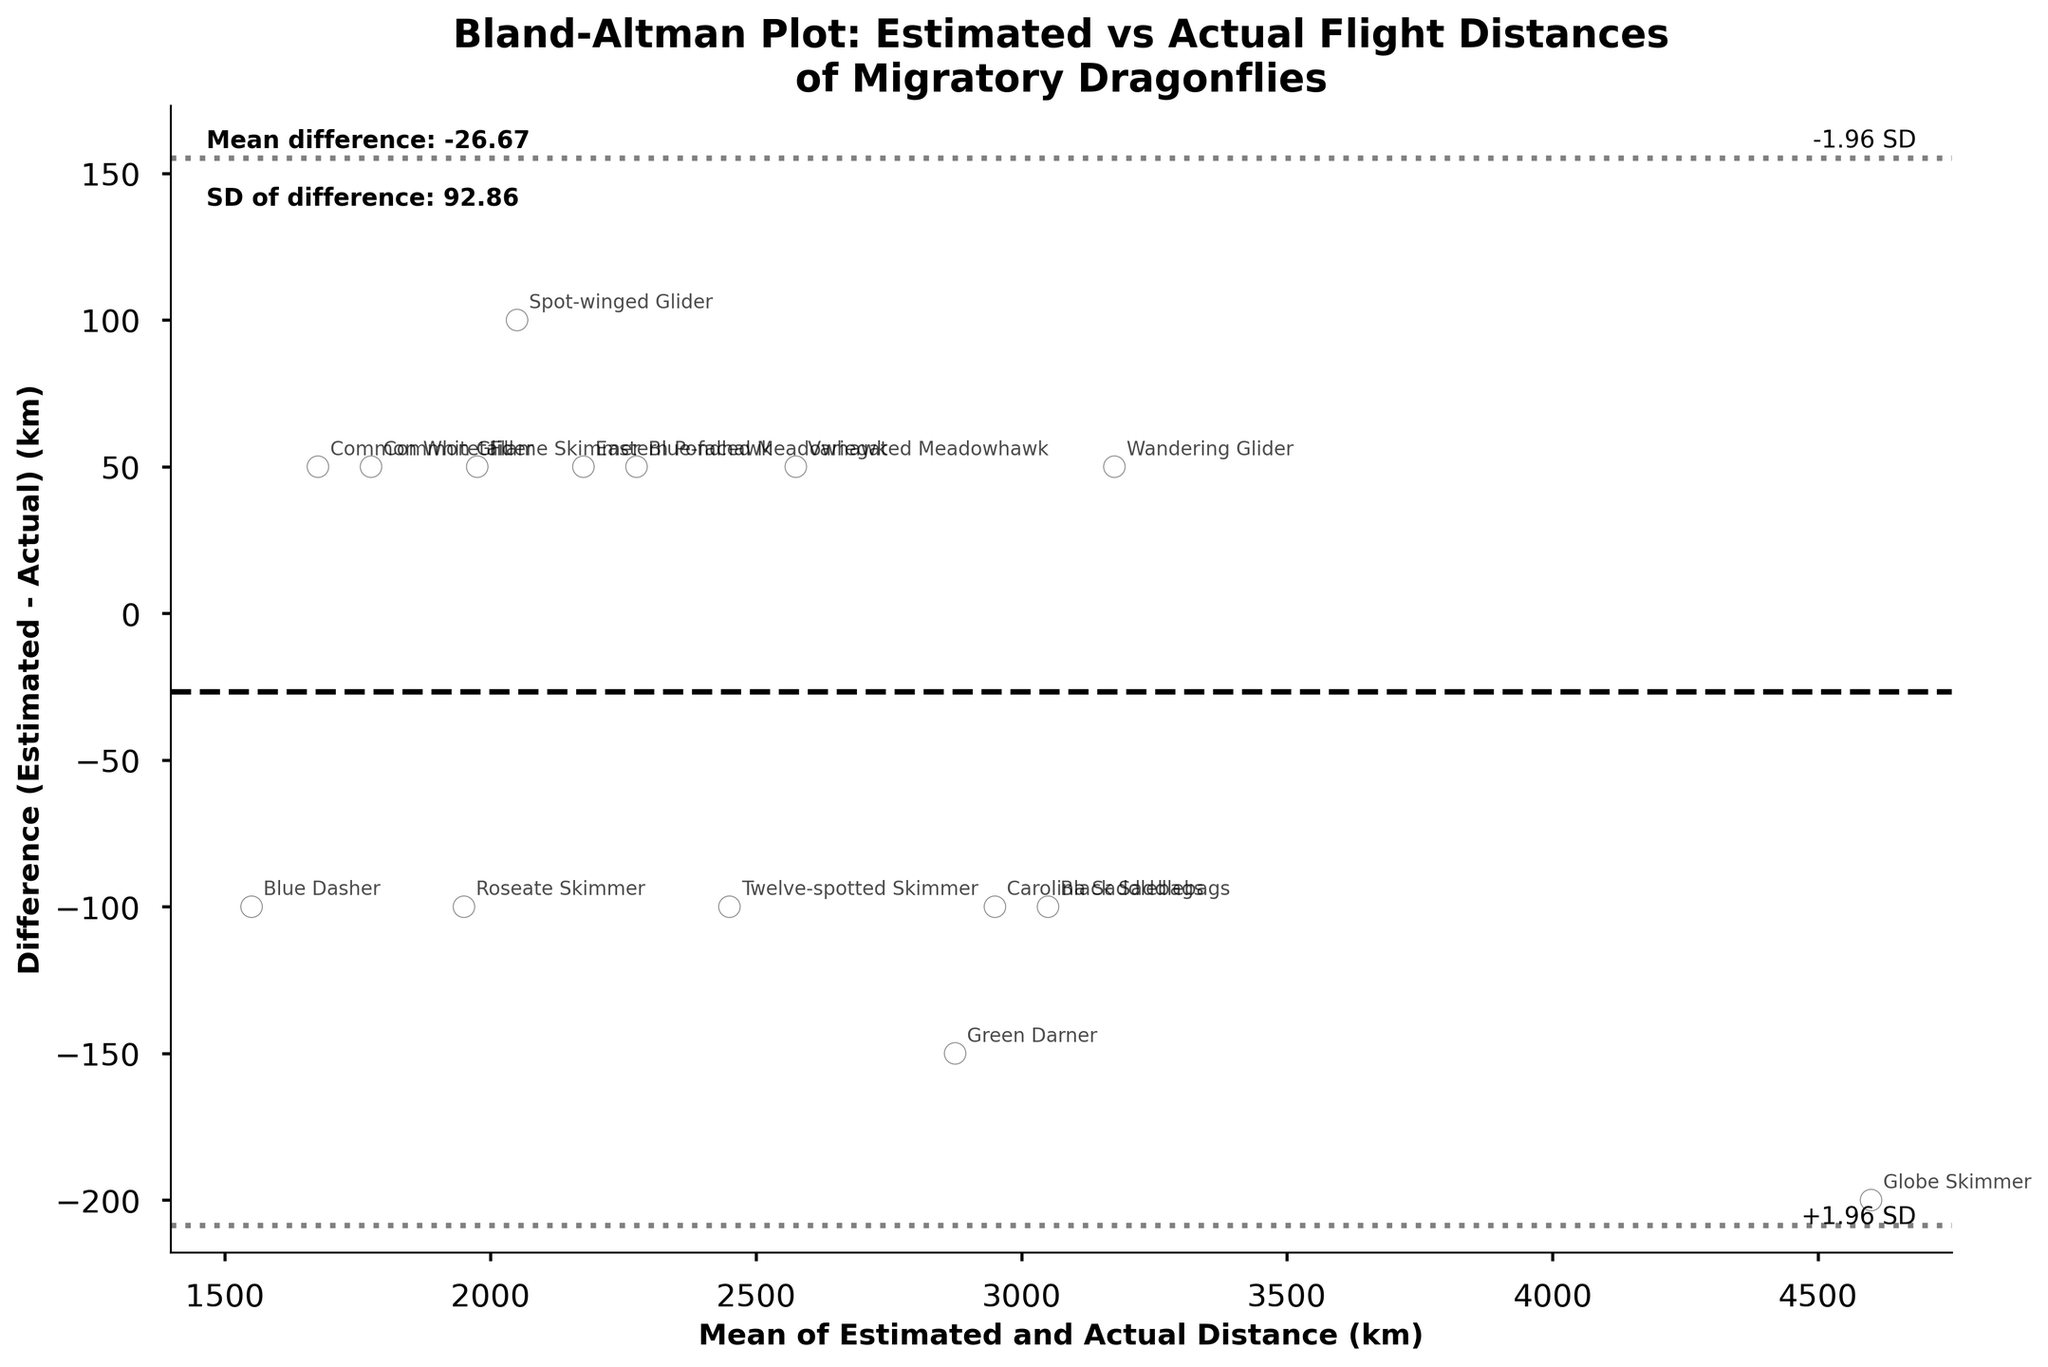What is the title of the plot? The title is usually found at the top of the plot and describes its overall content.
Answer: Bland-Altman Plot: Estimated vs Actual Flight Distances of Migratory Dragonflies How many dragonfly species are shown in the plot? Count the number of unique points or annotations on the plot, as each species is represented by a unique data point.
Answer: 15 What do the x-axis and y-axis represent in the plot? Read the labels on the axes to understand what each axis represents. The x-axis represents the mean of the estimated and actual distances, and the y-axis represents the difference between the estimated and actual distances.
Answer: The x-axis represents the Mean of Estimated and Actual Distance (km), and the y-axis represents the Difference (Estimated - Actual) (km) What does the dashed horizontal line in the middle of the plot represent? Observe the plot and describe the dashed line. It usually represents the mean difference which is marked as a reference line.
Answer: It represents the mean difference between the estimated and actual distances Which species is closest to the mean difference line? Identify the species annotated nearest to the dashed horizontal line representing the mean difference.
Answer: Roseate Skimmer What are the values of the mean difference and SD of the difference? Look for any textual information on the plot that details these statistics. It's usually found as annotations on the plot.
Answer: Mean difference: -23.33, SD of difference: 88.42 Which species has the largest positive difference between estimated and actual distances? Find the data point with the highest positive value on the y-axis and identify the species annotated at this position.
Answer: Common Glider Which species has the largest negative difference between estimated and actual distances? Find the data point with the lowest negative value on the y-axis and identify the species annotated at this position.
Answer: Globe Skimmer Are there any species with an estimated flight distance greater than the actual distance? Identify points located above the mean difference line, as these represent species where the estimated distance is greater than the actual distance.
Answer: Yes Considering the entire plot, do the estimated flight distances tend to overestimate or underestimate the actual flight distances? Look at the distribution of the points around the mean difference line. If most points are above the line, the estimates tend to overestimate; if below, they tend to underestimate.
Answer: Underestimate 